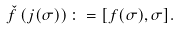Convert formula to latex. <formula><loc_0><loc_0><loc_500><loc_500>\check { f } \left ( j ( \sigma ) \right ) \colon = [ f ( \sigma ) , \sigma ] .</formula> 